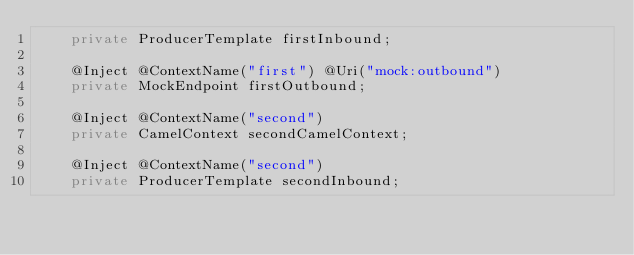Convert code to text. <code><loc_0><loc_0><loc_500><loc_500><_Java_>    private ProducerTemplate firstInbound;

    @Inject @ContextName("first") @Uri("mock:outbound")
    private MockEndpoint firstOutbound;

    @Inject @ContextName("second")
    private CamelContext secondCamelContext;

    @Inject @ContextName("second")
    private ProducerTemplate secondInbound;
</code> 